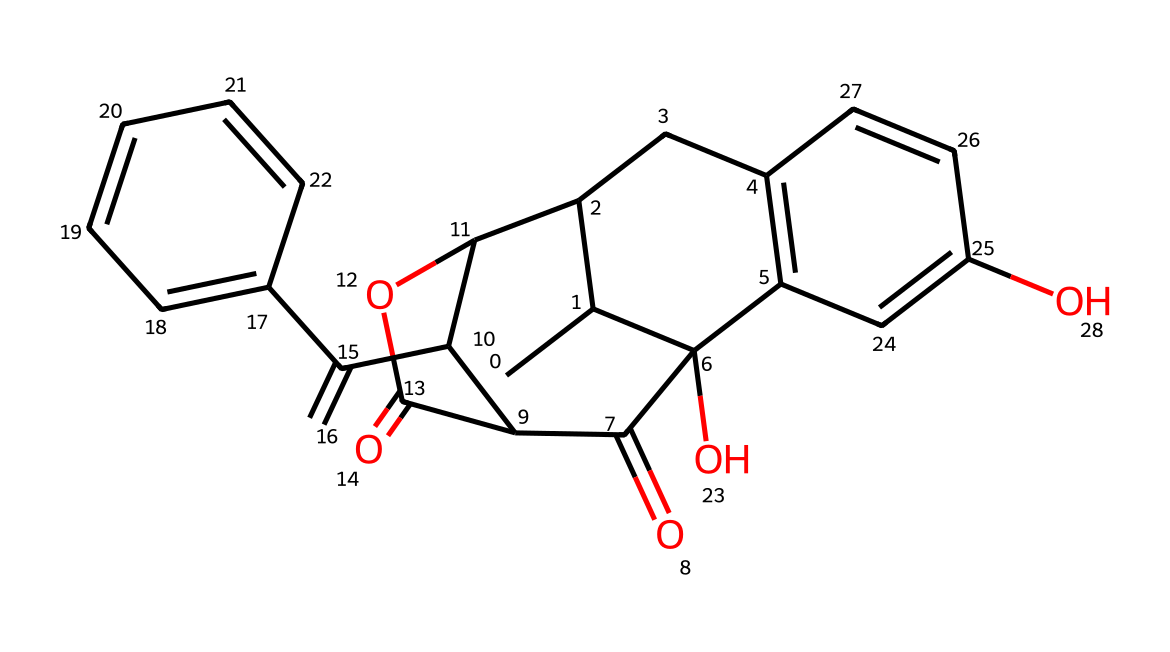What is the molecular formula of naloxone? To determine the molecular formula, we need to count the number of each type of atom in the SMILES representation. By breaking down the structure, we identify 17 carbons (C), 19 hydrogens (H), 2 oxygens (O), and 1 nitrogen (N). Thus, the molecular formula is C17H19N2O2.
Answer: C17H19N2O2 How many rings are present in the structure of naloxone? The presence of rings can be identified by looking for cyclic components in the SMILES notation. In this case, naloxone has three distinct cycles in its structure, which are part of the larger fused-ring system.
Answer: 3 What functional groups are present in naloxone? To identify functional groups, we need to look for characteristic elements and structures. The SMILES shows hydroxyl groups (-OH) and carbonyl groups (C=O). Therefore, the main functional groups in naloxone are alcohol (hydroxyl) and ketone (carbonyl) groups.
Answer: alcohol and ketone What is the significance of the nitrogen atom in the naloxone structure? The nitrogen atom in naloxone plays a crucial role in its pharmacological activity because it interacts with opioid receptors in the brain. This interaction is essential for naloxone's function as an opioid antagonist, countering the effects of opioid overdose.
Answer: opioid antagonist Which part of naloxone's structure helps it bind to opioid receptors? The region of naloxone that allows it to bind to opioid receptors is typically the nitrogen-containing portion or the alkaloid-like structure. This structure is similar to that of natural opioids, facilitating effective receptor interaction.
Answer: nitrogen-containing portion 